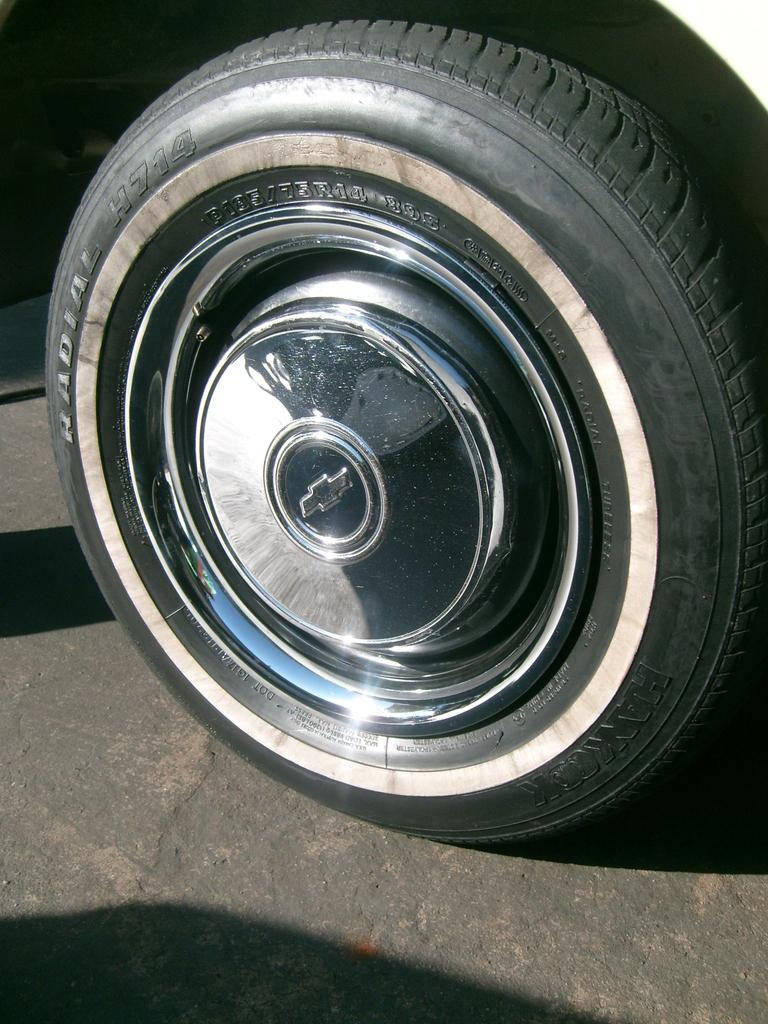What object related to a vehicle can be seen in the image? There is a Tyre of a vehicle in the image. What is located in the middle of the Tyre? There is a metal in the middle of the Tyre. Where is the Tyre placed in the image? The Tyre is on the floor. Can you see a robin perched on the Tyre in the image? No, there is no robin present in the image. Is the garden visible in the background of the image? The provided facts do not mention a garden, so it cannot be determined from the image. 